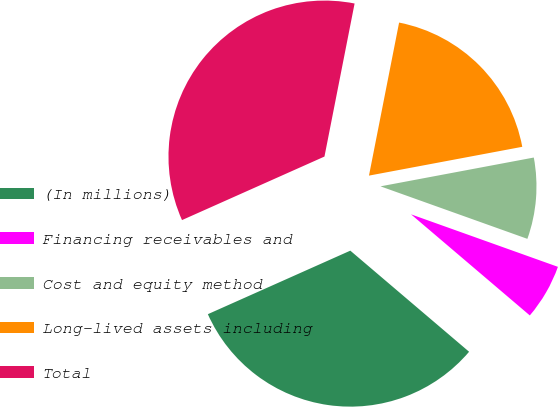Convert chart to OTSL. <chart><loc_0><loc_0><loc_500><loc_500><pie_chart><fcel>(In millions)<fcel>Financing receivables and<fcel>Cost and equity method<fcel>Long-lived assets including<fcel>Total<nl><fcel>32.1%<fcel>5.76%<fcel>8.42%<fcel>18.95%<fcel>34.77%<nl></chart> 